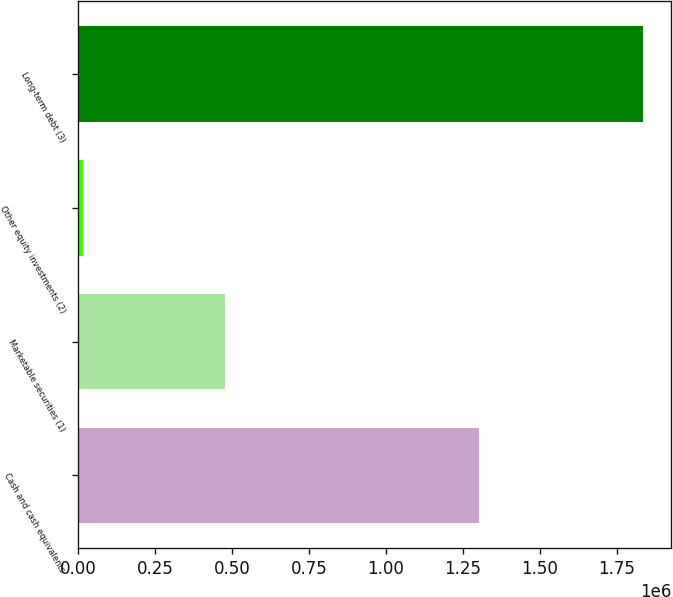Convert chart. <chart><loc_0><loc_0><loc_500><loc_500><bar_chart><fcel>Cash and cash equivalents<fcel>Marketable securities (1)<fcel>Other equity investments (2)<fcel>Long-term debt (3)<nl><fcel>1.3026e+06<fcel>476599<fcel>15018<fcel>1.83485e+06<nl></chart> 